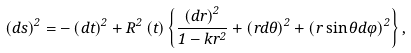<formula> <loc_0><loc_0><loc_500><loc_500>( d s ) ^ { 2 } = - \left ( d t \right ) ^ { 2 } + R ^ { 2 } \left ( t \right ) \left \{ \frac { \left ( d r \right ) ^ { 2 } } { 1 - k r ^ { 2 } } + \left ( r d \theta \right ) ^ { 2 } + \left ( r \sin \theta d \varphi \right ) ^ { 2 } \right \} ,</formula> 